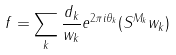<formula> <loc_0><loc_0><loc_500><loc_500>f = \sum _ { k } \frac { d _ { k } } { \| w _ { k } \| } e ^ { 2 \pi i \theta _ { k } } ( S ^ { M _ { k } } w _ { k } )</formula> 